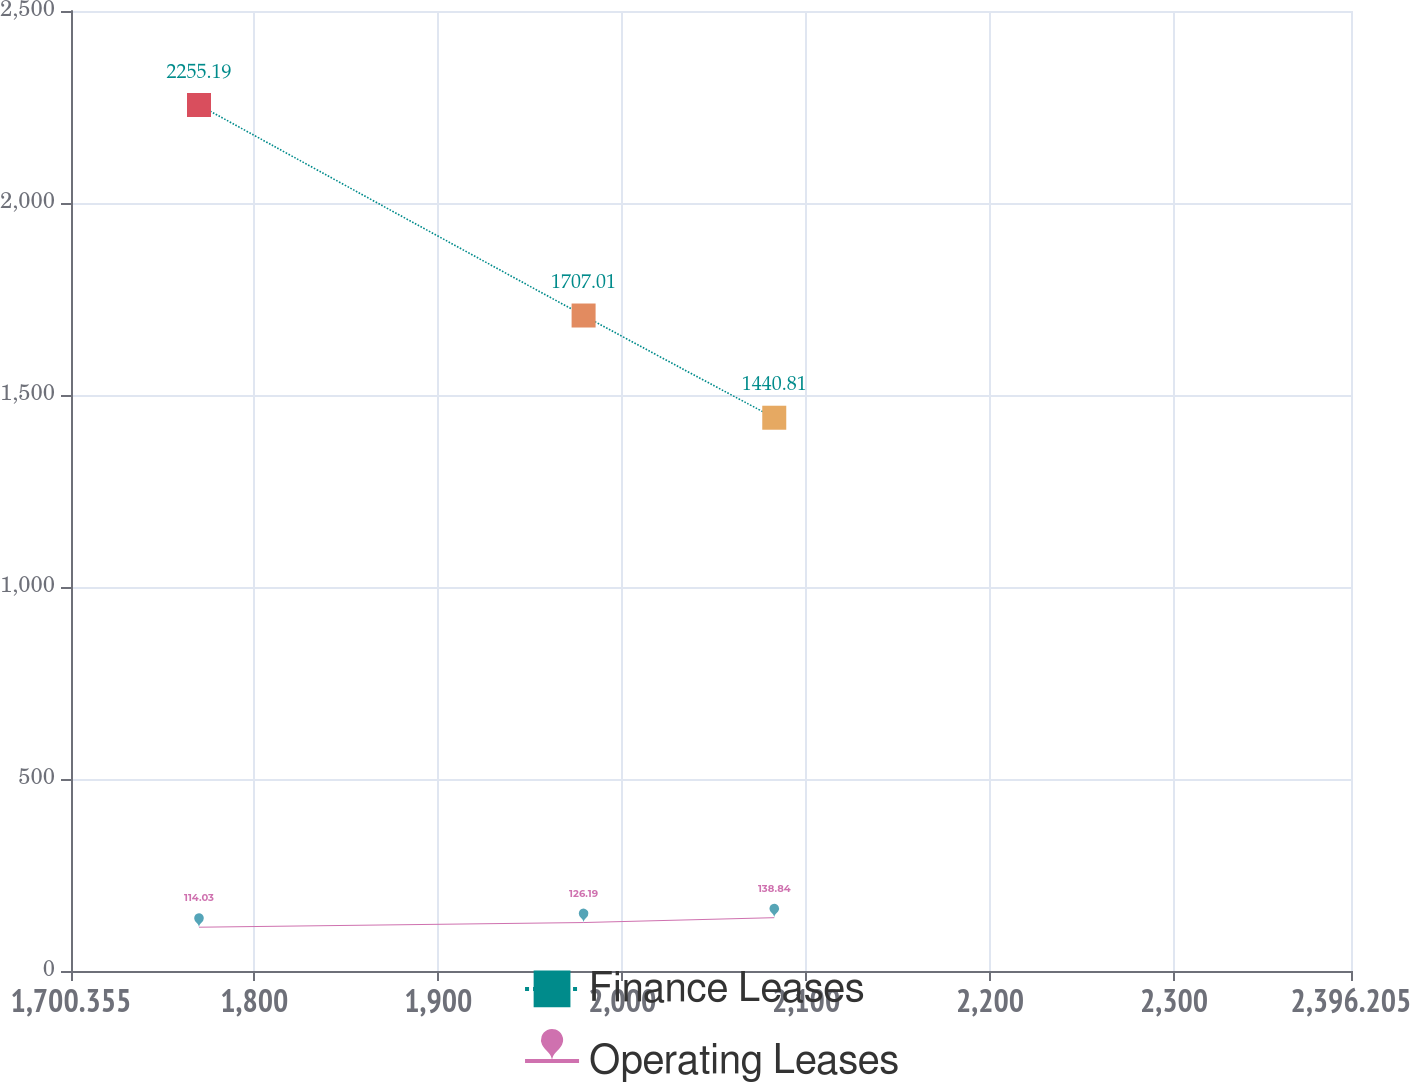Convert chart. <chart><loc_0><loc_0><loc_500><loc_500><line_chart><ecel><fcel>Finance Leases<fcel>Operating Leases<nl><fcel>1769.94<fcel>2255.19<fcel>114.03<nl><fcel>1979.02<fcel>1707.01<fcel>126.19<nl><fcel>2082.67<fcel>1440.81<fcel>138.84<nl><fcel>2400.69<fcel>1592.58<fcel>108.94<nl><fcel>2465.79<fcel>1235.56<fcel>87.98<nl></chart> 